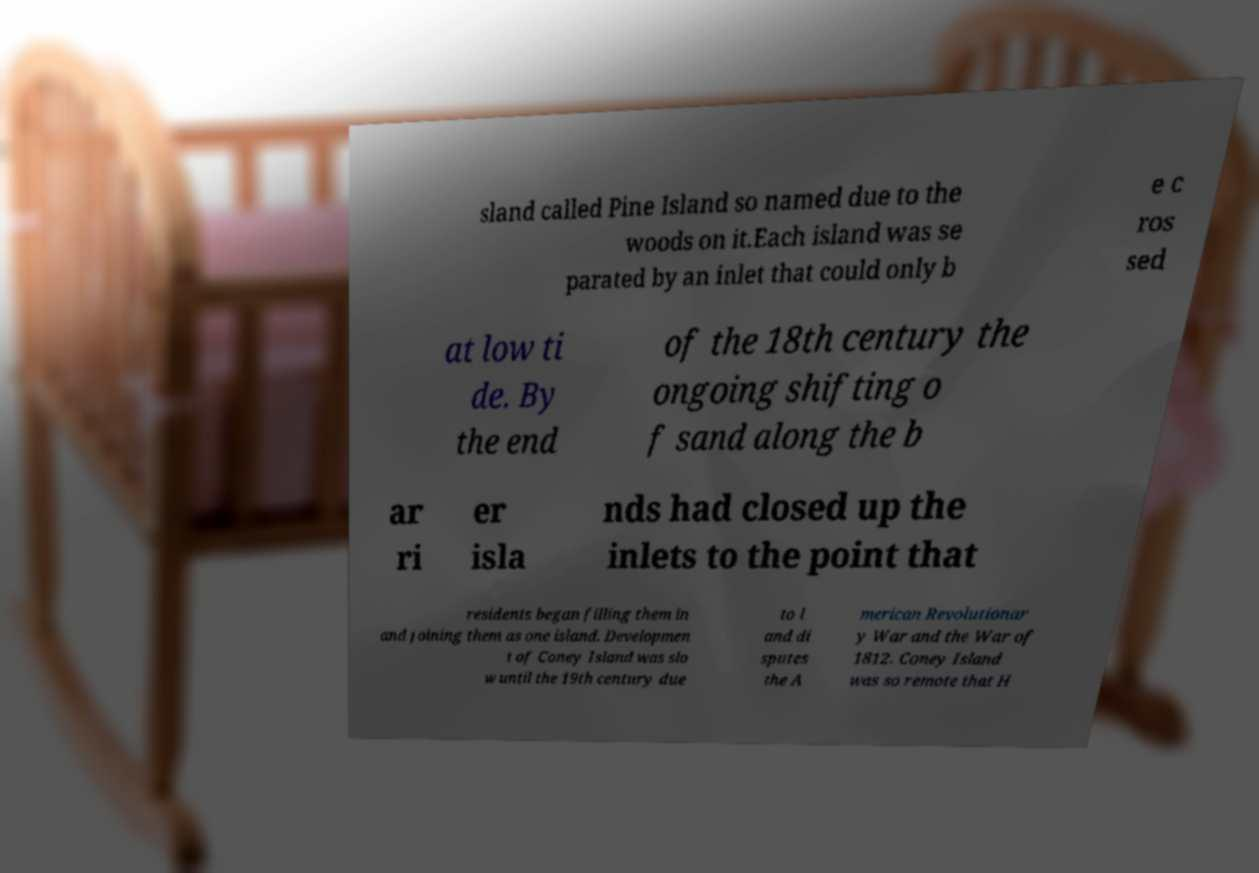Please identify and transcribe the text found in this image. sland called Pine Island so named due to the woods on it.Each island was se parated by an inlet that could only b e c ros sed at low ti de. By the end of the 18th century the ongoing shifting o f sand along the b ar ri er isla nds had closed up the inlets to the point that residents began filling them in and joining them as one island. Developmen t of Coney Island was slo w until the 19th century due to l and di sputes the A merican Revolutionar y War and the War of 1812. Coney Island was so remote that H 